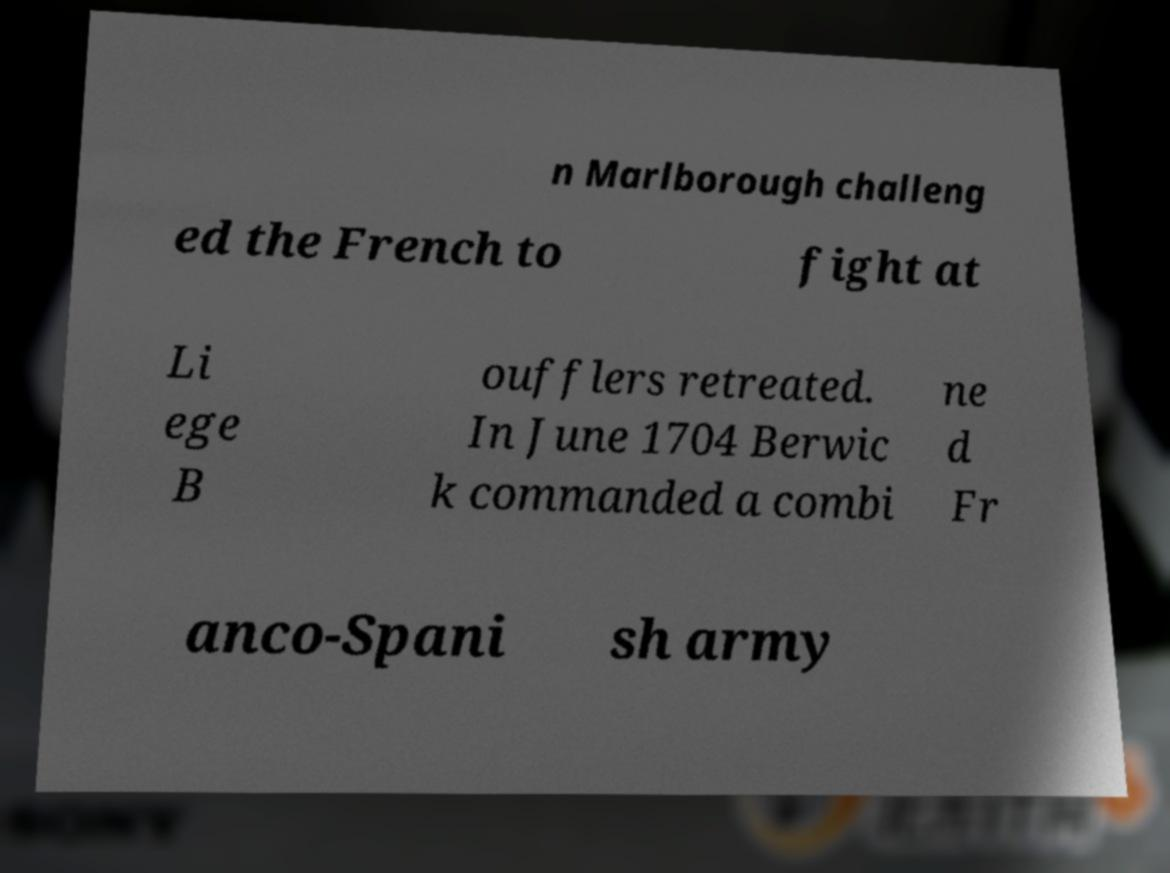Please identify and transcribe the text found in this image. n Marlborough challeng ed the French to fight at Li ege B oufflers retreated. In June 1704 Berwic k commanded a combi ne d Fr anco-Spani sh army 